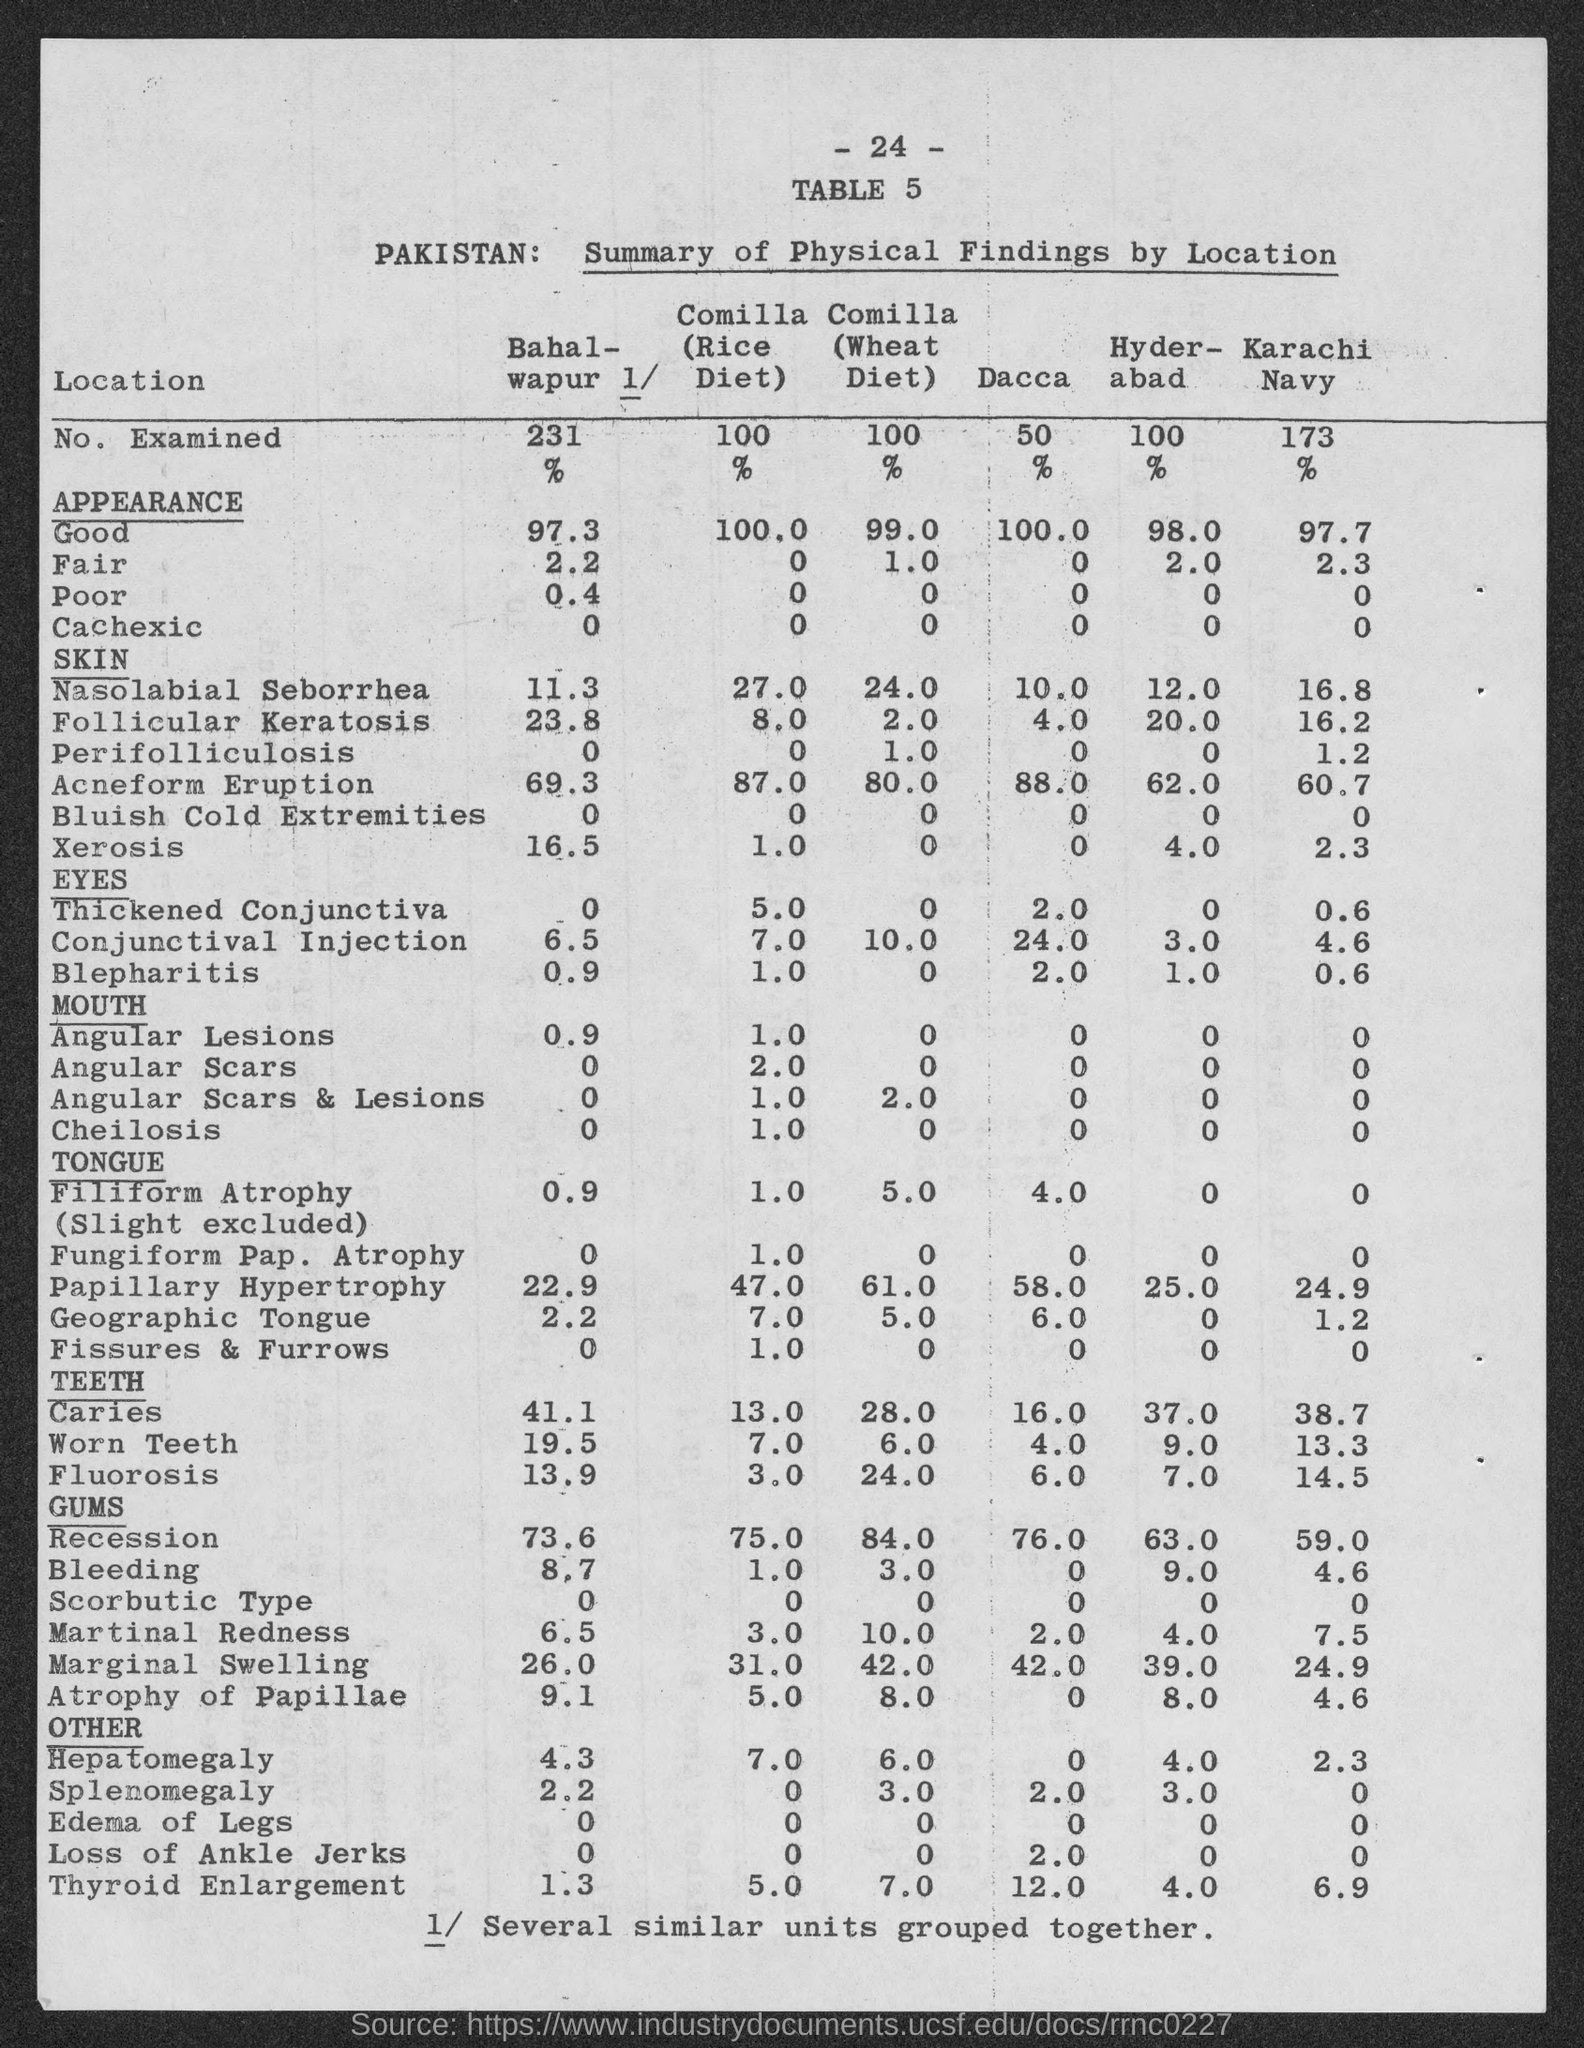What is the number at top of the page ?
Provide a short and direct response. - 24 -. What is the table no.?
Your response must be concise. 5. What is the no. of examined in commila (rice diet)?
Ensure brevity in your answer.  100. What is the no. of examined in bahalwapur ?
Offer a terse response. 231. What is the no. of examined in comilla (wheat diet)?
Provide a short and direct response. 100. What is the no. examined in dacca ?
Give a very brief answer. 50. What is the no. of examined in hyderabad ?
Your answer should be very brief. 100. What is the no. of examined in karachi navy?
Give a very brief answer. 173. 